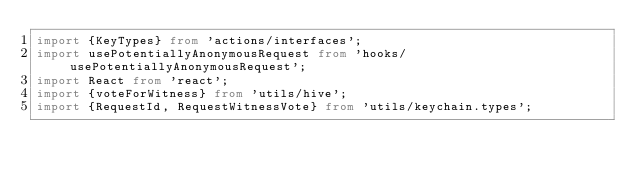<code> <loc_0><loc_0><loc_500><loc_500><_TypeScript_>import {KeyTypes} from 'actions/interfaces';
import usePotentiallyAnonymousRequest from 'hooks/usePotentiallyAnonymousRequest';
import React from 'react';
import {voteForWitness} from 'utils/hive';
import {RequestId, RequestWitnessVote} from 'utils/keychain.types';</code> 